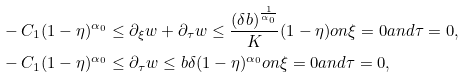Convert formula to latex. <formula><loc_0><loc_0><loc_500><loc_500>& - C _ { 1 } ( 1 - \eta ) ^ { \alpha _ { 0 } } \leq \partial _ { \xi } w + \partial _ { \tau } w \leq \frac { ( \delta b ) ^ { \frac { 1 } { \alpha _ { 0 } } } } { K } ( 1 - \eta ) o n \xi = 0 a n d \tau = 0 , \\ & - C _ { 1 } ( 1 - \eta ) ^ { \alpha _ { 0 } } \leq \partial _ { \tau } w \leq b \delta ( 1 - \eta ) ^ { \alpha _ { 0 } } o n \xi = 0 a n d \tau = 0 ,</formula> 